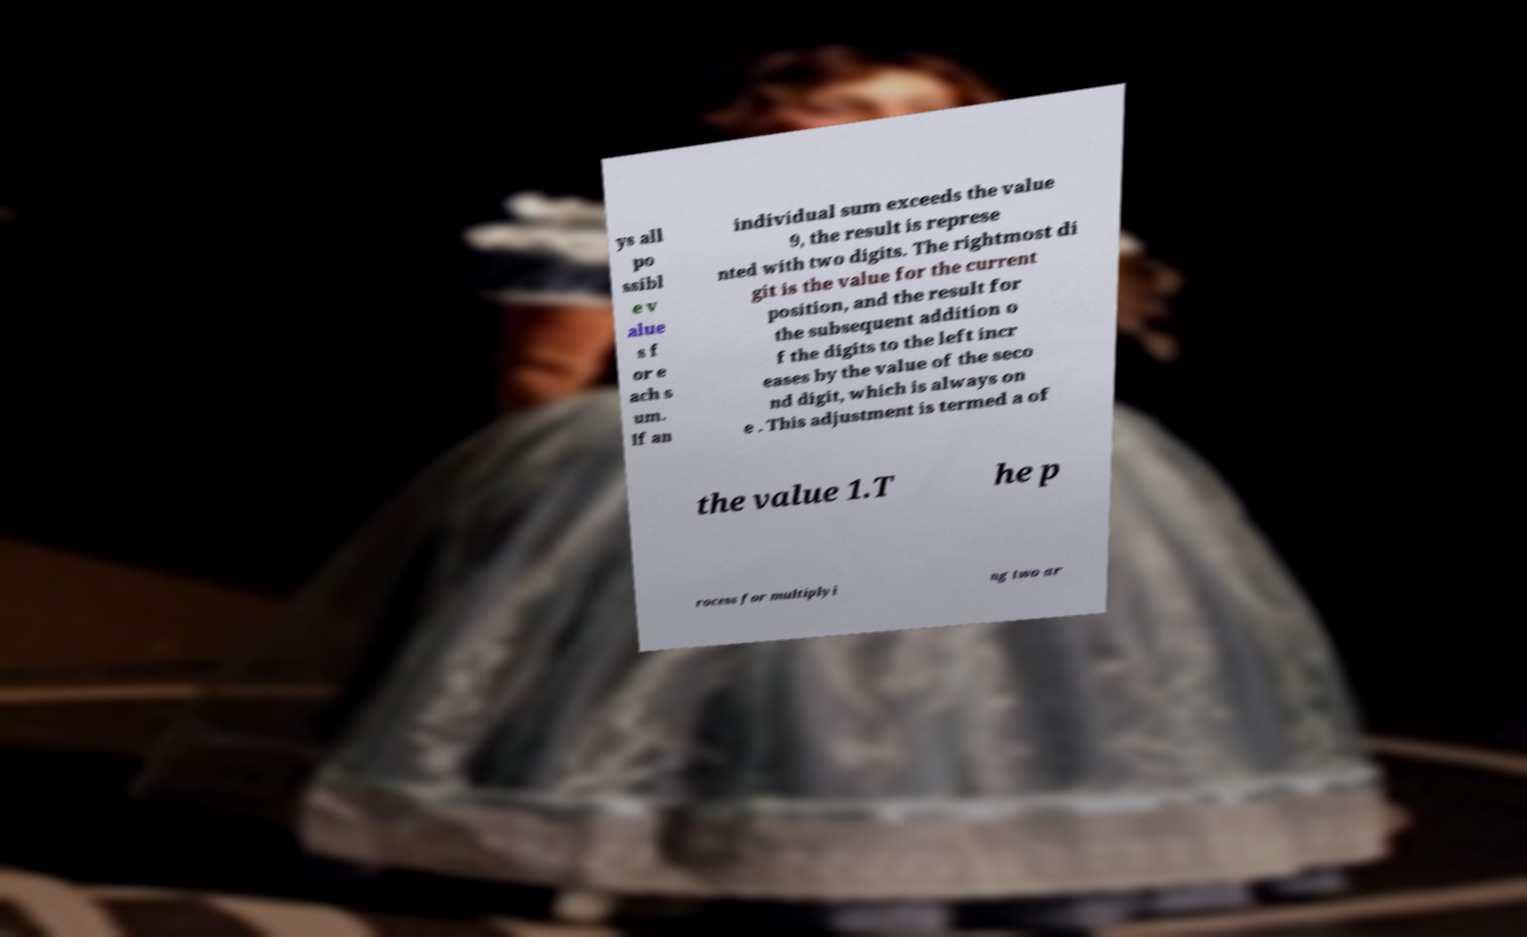Please identify and transcribe the text found in this image. ys all po ssibl e v alue s f or e ach s um. If an individual sum exceeds the value 9, the result is represe nted with two digits. The rightmost di git is the value for the current position, and the result for the subsequent addition o f the digits to the left incr eases by the value of the seco nd digit, which is always on e . This adjustment is termed a of the value 1.T he p rocess for multiplyi ng two ar 